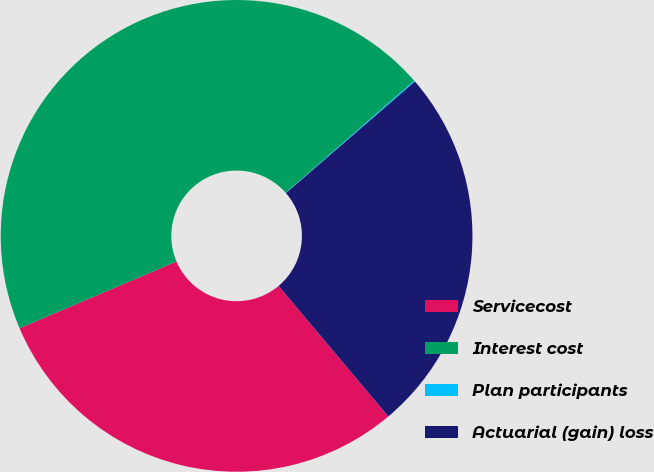<chart> <loc_0><loc_0><loc_500><loc_500><pie_chart><fcel>Servicecost<fcel>Interest cost<fcel>Plan participants<fcel>Actuarial (gain) loss<nl><fcel>29.72%<fcel>44.97%<fcel>0.08%<fcel>25.23%<nl></chart> 